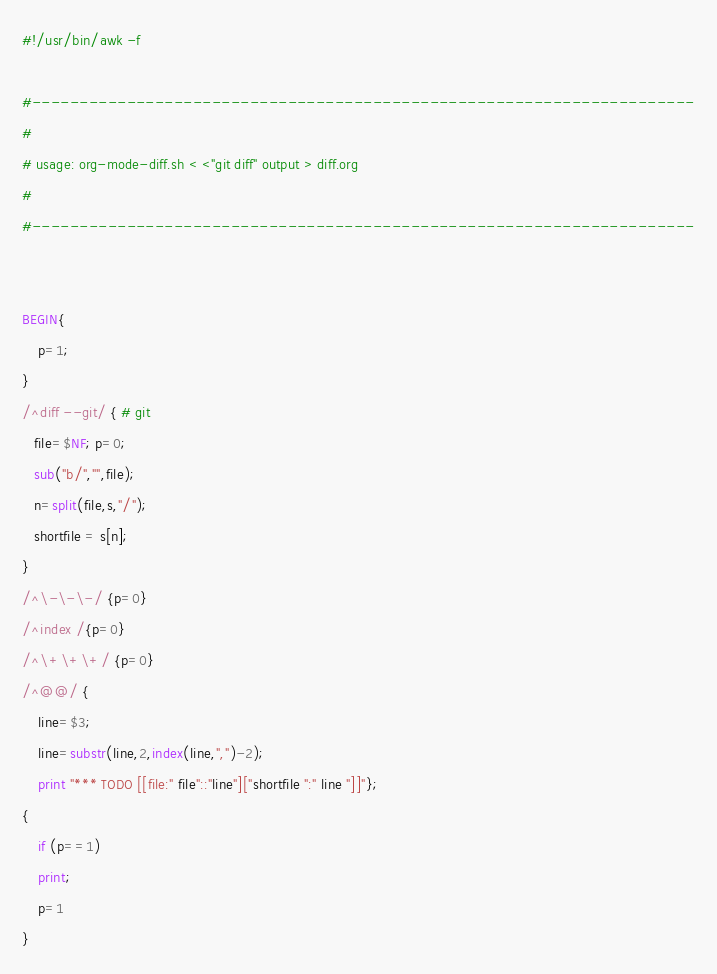<code> <loc_0><loc_0><loc_500><loc_500><_Awk_>#!/usr/bin/awk -f

#----------------------------------------------------------------------
#
# usage: org-mode-diff.sh < <"git diff" output > diff.org
#
#----------------------------------------------------------------------


BEGIN{
    p=1;
}
/^diff --git/ { # git
   file=$NF; p=0;
   sub("b/","",file);
   n=split(file,s,"/");
   shortfile = s[n];
}
/^\-\-\-/ {p=0}
/^index /{p=0}
/^\+\+\+/ {p=0}
/^@@/ {
    line=$3;
    line=substr(line,2,index(line,",")-2);
    print "*** TODO [[file:" file"::"line"]["shortfile ":" line "]]"};
{
    if (p==1)
	print;
    p=1
}
</code> 